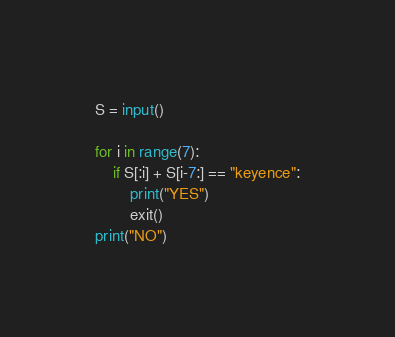Convert code to text. <code><loc_0><loc_0><loc_500><loc_500><_Python_>S = input()
 
for i in range(7):
	if S[:i] + S[i-7:] == "keyence":
		print("YES")
		exit()
print("NO")</code> 